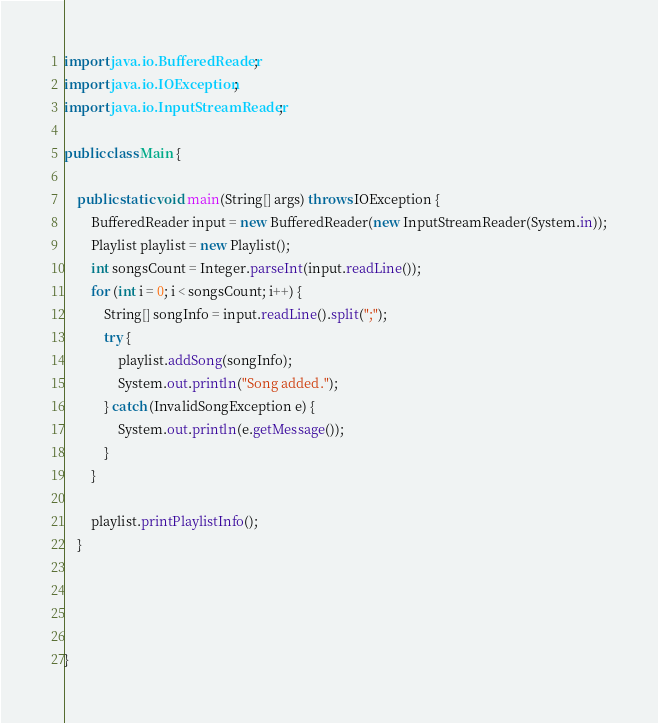Convert code to text. <code><loc_0><loc_0><loc_500><loc_500><_Java_>import java.io.BufferedReader;
import java.io.IOException;
import java.io.InputStreamReader;

public class Main {

    public static void main(String[] args) throws IOException {
        BufferedReader input = new BufferedReader(new InputStreamReader(System.in));
        Playlist playlist = new Playlist();
        int songsCount = Integer.parseInt(input.readLine());
        for (int i = 0; i < songsCount; i++) {
            String[] songInfo = input.readLine().split(";");
            try {
                playlist.addSong(songInfo);
                System.out.println("Song added.");
            } catch (InvalidSongException e) {
                System.out.println(e.getMessage());
            }
        }

        playlist.printPlaylistInfo();
    }




}
</code> 